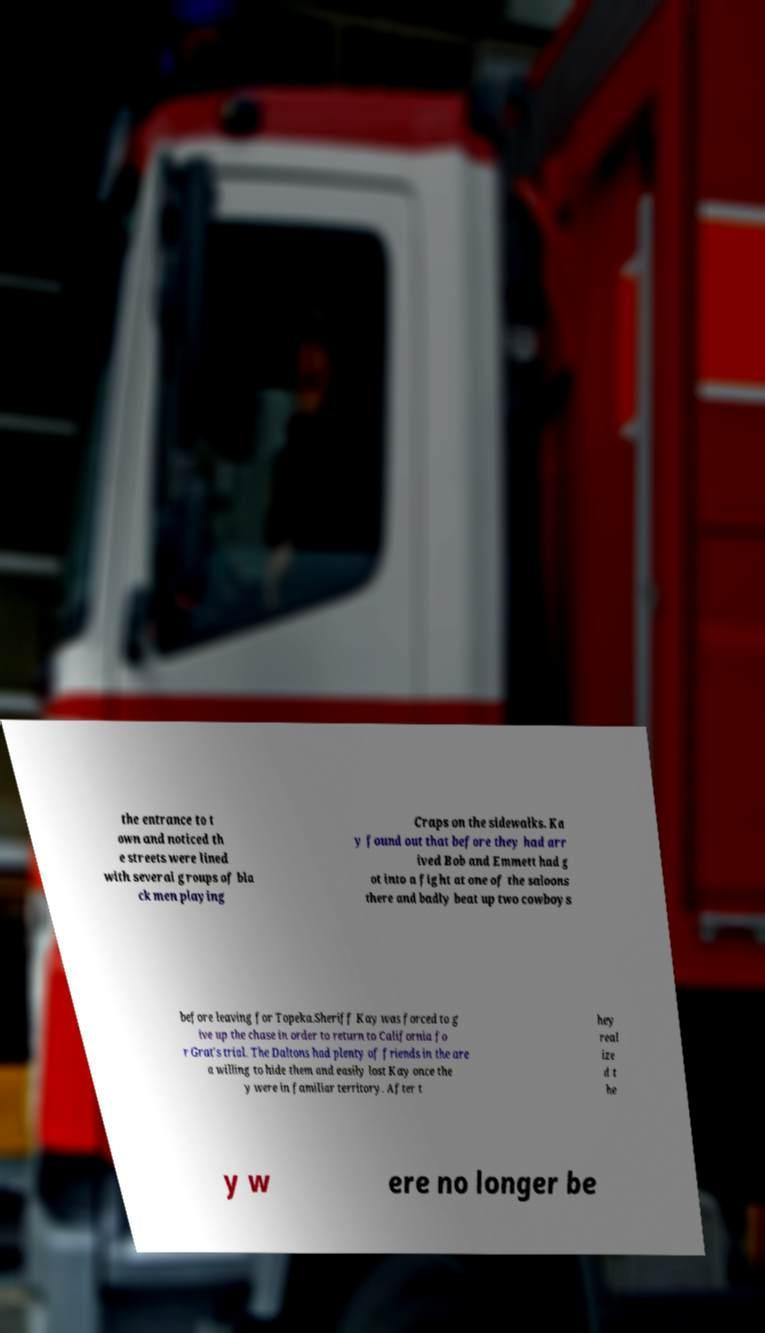What messages or text are displayed in this image? I need them in a readable, typed format. the entrance to t own and noticed th e streets were lined with several groups of bla ck men playing Craps on the sidewalks. Ka y found out that before they had arr ived Bob and Emmett had g ot into a fight at one of the saloons there and badly beat up two cowboys before leaving for Topeka.Sheriff Kay was forced to g ive up the chase in order to return to California fo r Grat's trial. The Daltons had plenty of friends in the are a willing to hide them and easily lost Kay once the y were in familiar territory. After t hey real ize d t he y w ere no longer be 